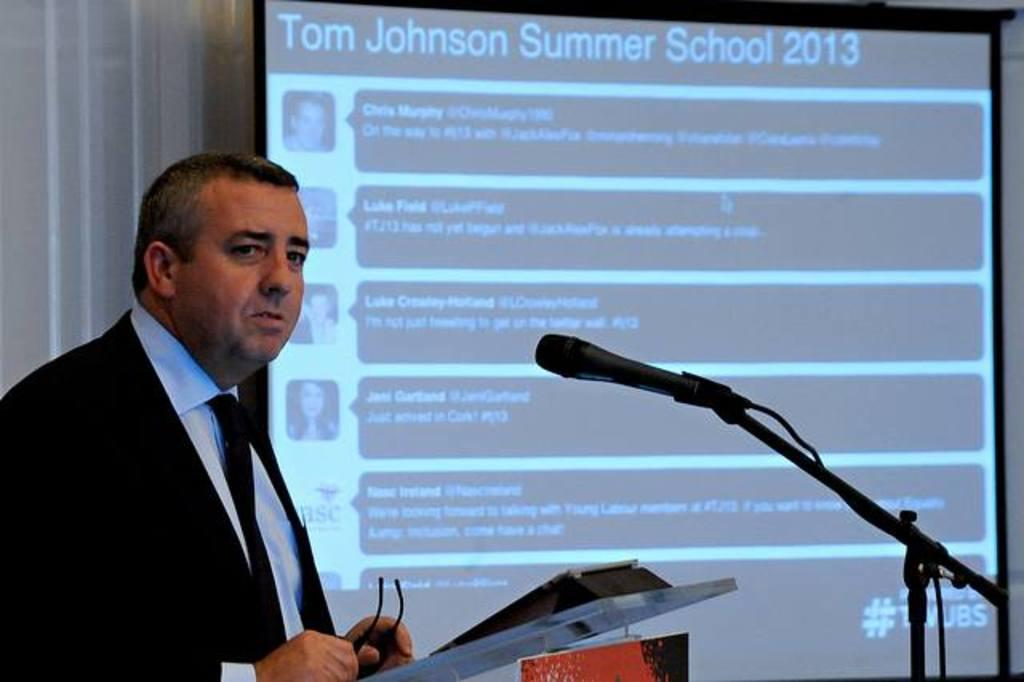What is the main subject of the image? There is a person in the image. What is the person holding in the image? The person is holding an object. What is in front of the person? There is a podium and a microphone in front of the person. What can be seen in the background of the image? There is a curtain and a projector screen in the background of the image. What type of stone is being weighed on the scale in the image? There is no scale or stone present in the image. 